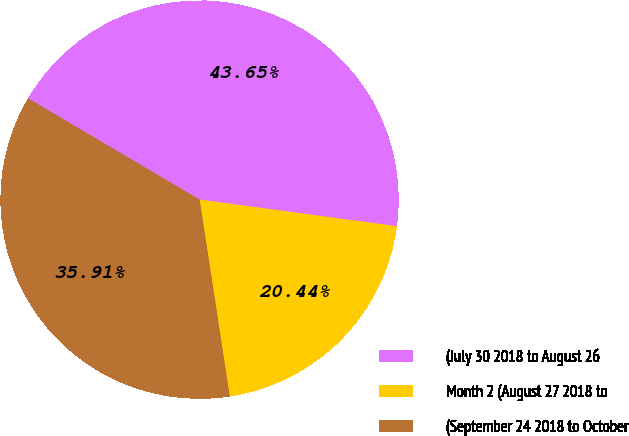Convert chart to OTSL. <chart><loc_0><loc_0><loc_500><loc_500><pie_chart><fcel>(July 30 2018 to August 26<fcel>Month 2 (August 27 2018 to<fcel>(September 24 2018 to October<nl><fcel>43.65%<fcel>20.44%<fcel>35.91%<nl></chart> 